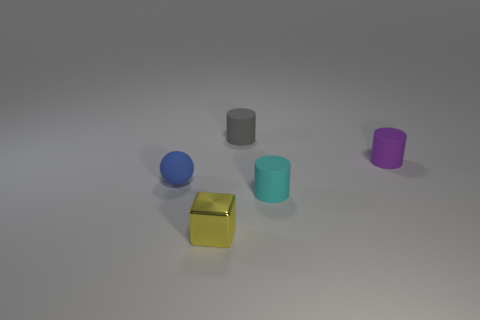Is the number of purple matte cylinders in front of the blue rubber sphere the same as the number of small metallic things left of the metallic object?
Your answer should be very brief. Yes. Are there any tiny gray cylinders in front of the ball?
Provide a succinct answer. No. What color is the rubber cylinder that is on the right side of the tiny cyan cylinder?
Offer a terse response. Purple. The small object that is right of the cylinder in front of the purple rubber thing is made of what material?
Offer a terse response. Rubber. Are there fewer tiny matte cylinders in front of the tiny cyan rubber cylinder than tiny blue rubber things on the right side of the tiny blue rubber thing?
Give a very brief answer. No. How many blue objects are tiny balls or big shiny cubes?
Ensure brevity in your answer.  1. Are there the same number of matte cylinders that are to the right of the tiny block and cyan things?
Keep it short and to the point. No. What number of objects are either tiny purple cylinders or cylinders right of the small cyan cylinder?
Offer a very short reply. 1. Does the tiny matte sphere have the same color as the metal block?
Your answer should be compact. No. Is there a purple object that has the same material as the small yellow cube?
Your response must be concise. No. 